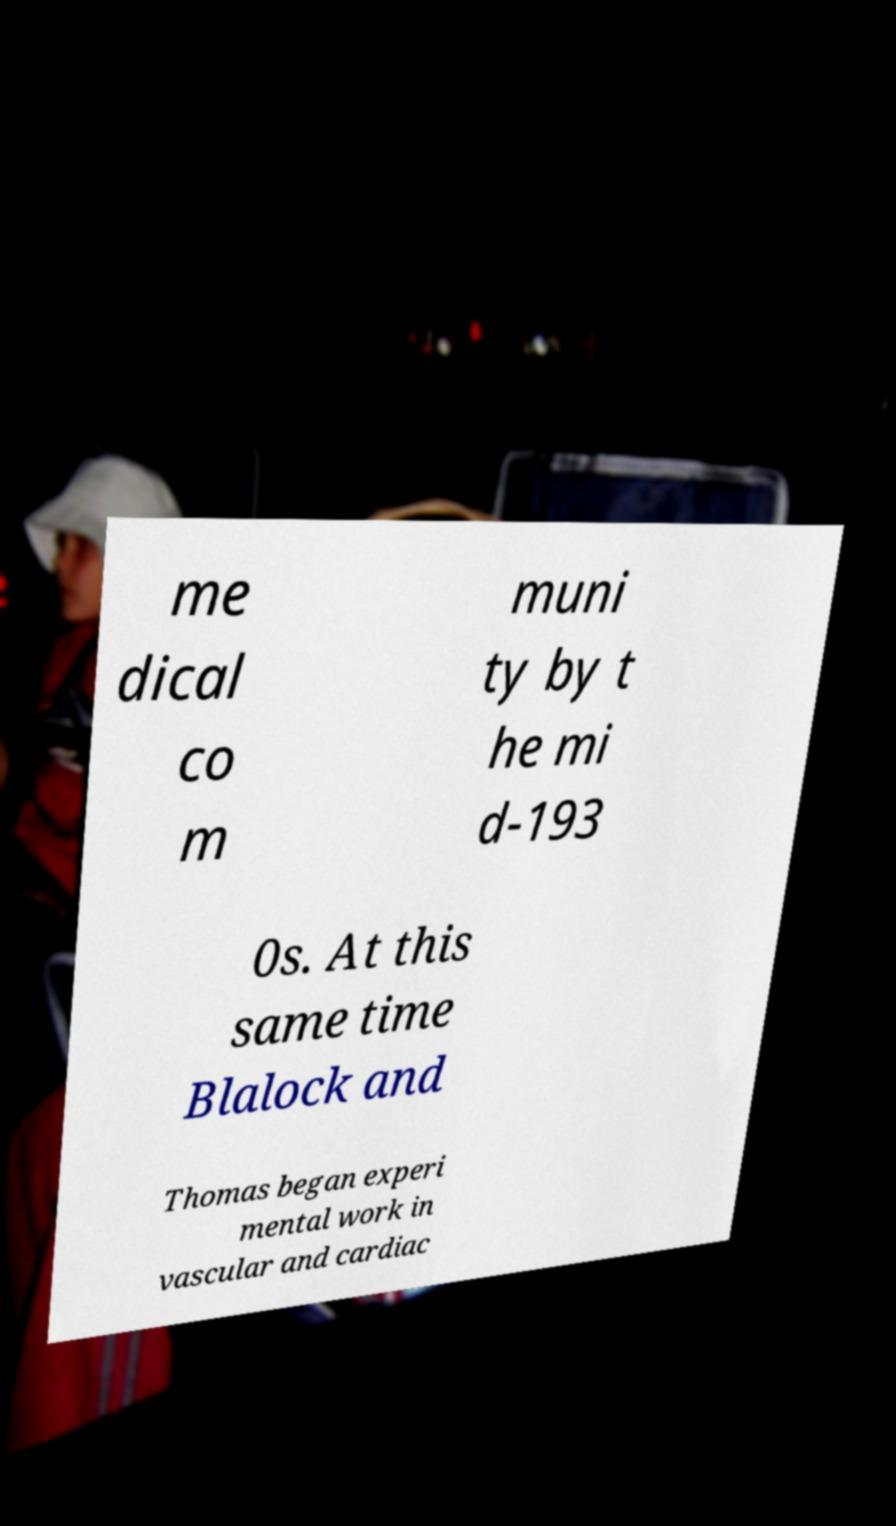Can you accurately transcribe the text from the provided image for me? me dical co m muni ty by t he mi d-193 0s. At this same time Blalock and Thomas began experi mental work in vascular and cardiac 